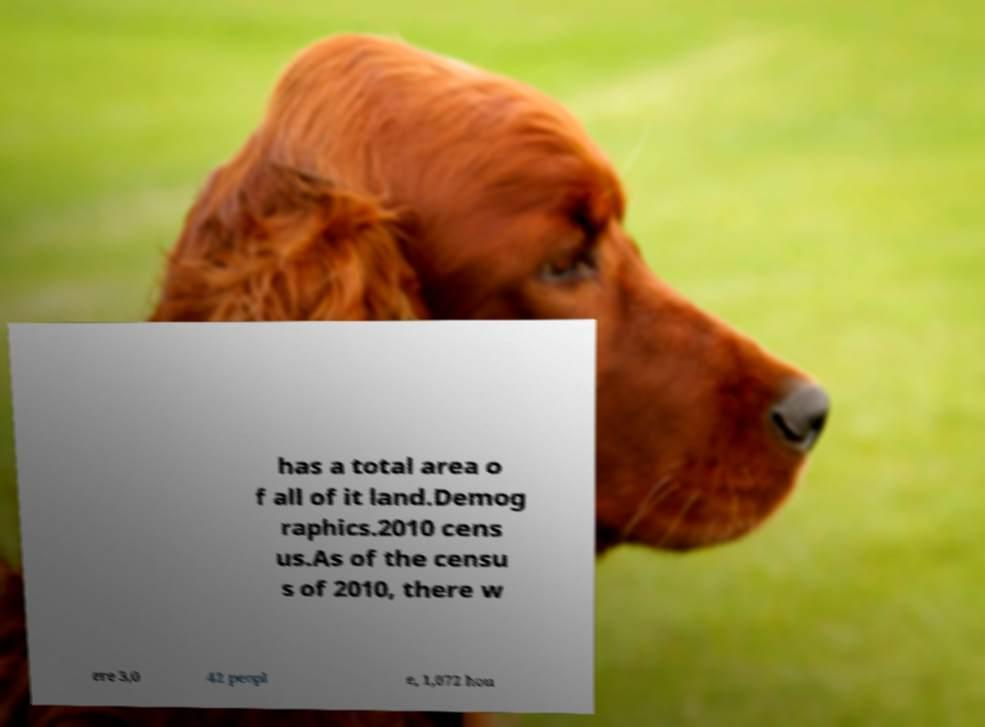Could you assist in decoding the text presented in this image and type it out clearly? has a total area o f all of it land.Demog raphics.2010 cens us.As of the censu s of 2010, there w ere 3,0 42 peopl e, 1,072 hou 